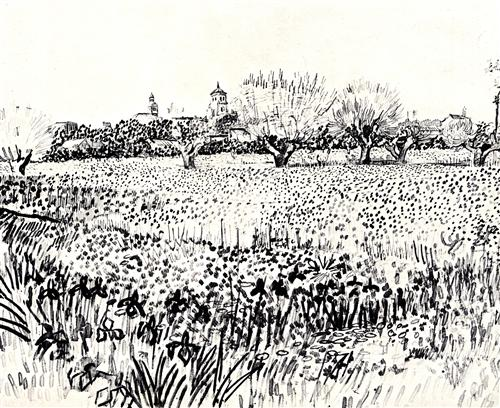Can you describe the main features of this image for me? This black and white sketch brilliantly captures a detailed impressionistic landscape. The foreground is teeming with tall grasses and wildflowers, rendered in loose and flowing lines that convey depth and distance. Moving beyond the field, one can observe a row of bare-branched trees alongside houses with pointed roofs, each element meticulously shaded to showcase their textures. Wispy clouds populate the sky, enhancing the scene's serene atmosphere. Despite the lack of color, the artist's expert use of shading and line work vividly brings out the rich details of this tranquil landscape. 